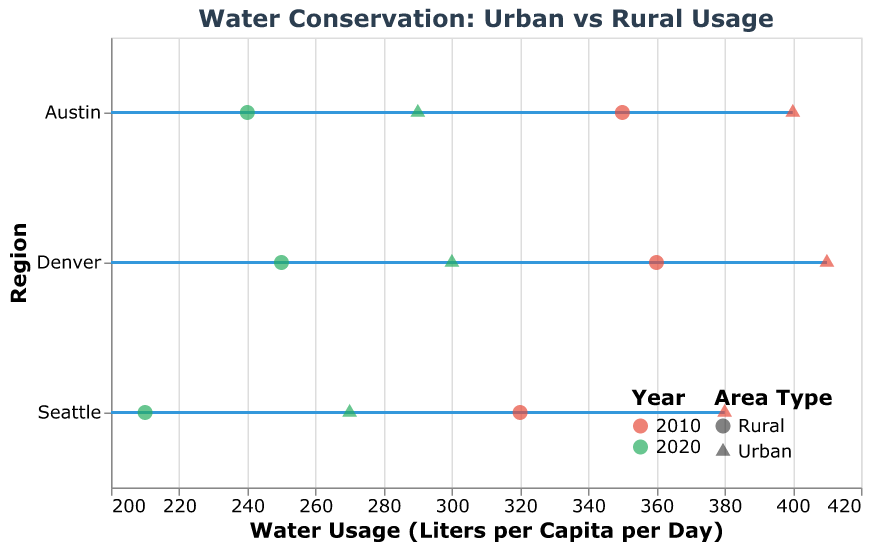How many different regions are displayed in the plot? The plot indicates data points classified by three distinct regions, which are shown on the y-axis as Austin, Seattle, and Denver.
Answer: 3 What is the color scheme used to represent different years? By observing the legend at the bottom-right, we see the year 2010 is colored red, while the year 2020 is colored green.
Answer: Red and green Which region has the highest urban water usage in 2010? Evaluate the urban data points for each region in 2010. Austin shows 400, Seattle shows 380, and Denver shows 410. Therefore, Denver has the highest urban water usage in 2010.
Answer: Denver What is the difference in water usage between urban and rural areas in Austin for the year 2020? For Austin in 2020, the water usage is 290 liters per capita per day for urban areas and 240 for rural areas. The difference is 290 - 240.
Answer: 50 By how much did water usage in Seattle's rural areas decrease from 2010 to 2020? For Seattle rural areas, water usage in 2010 was 320 liters per capita per day, and in 2020 it was 210. The decrease is 320 - 210.
Answer: 110 Which area type, urban or rural, saw a greater reduction in water usage in Denver from 2010 to 2020? In Denver, the urban water usage dropped from 410 to 300, a reduction of 110 liters. The rural water usage dropped from 360 to 250, a reduction of 110 liters. Therefore, both urban and rural areas saw the same reduction.
Answer: Both equal Is there an area type (urban or rural) where any of the regions did not achieve a usage reduction of at least 100 liters per capita per day from 2010 to 2020? Examine each area type across all regions: 
- Austin: Urban reduction (400 to 290 = 110), Rural reduction (350 to 240 = 110)
- Seattle: Urban reduction (380 to 270 = 110), Rural reduction (320 to 210 = 110)
- Denver: Urban reduction (410 to 300 = 110), Rural reduction (360 to 250 = 110)
All area types in all regions achieved at least a 100 liter reduction.
Answer: No 